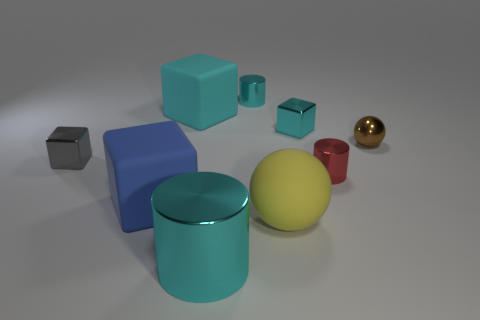Subtract all blue spheres. Subtract all gray blocks. How many spheres are left? 2 Subtract all balls. How many objects are left? 7 Add 1 small gray blocks. How many small gray blocks exist? 2 Subtract 0 brown cylinders. How many objects are left? 9 Subtract all small metal objects. Subtract all brown metallic objects. How many objects are left? 3 Add 3 small cyan things. How many small cyan things are left? 5 